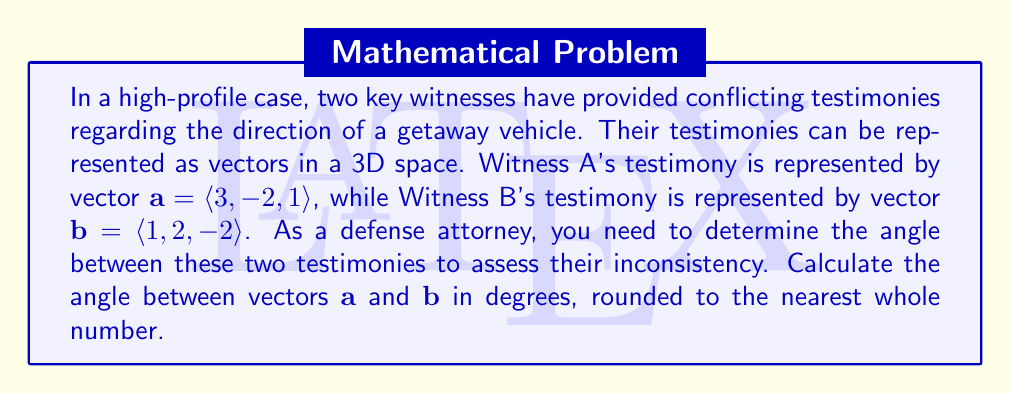Provide a solution to this math problem. To find the angle between two vectors, we can use the dot product formula:

$$\cos \theta = \frac{\mathbf{a} \cdot \mathbf{b}}{|\mathbf{a}||\mathbf{b}|}$$

Where $\theta$ is the angle between the vectors, $\mathbf{a} \cdot \mathbf{b}$ is the dot product, and $|\mathbf{a}|$ and $|\mathbf{b}|$ are the magnitudes of the vectors.

Step 1: Calculate the dot product $\mathbf{a} \cdot \mathbf{b}$
$$\mathbf{a} \cdot \mathbf{b} = (3)(1) + (-2)(2) + (1)(-2) = 3 - 4 - 2 = -3$$

Step 2: Calculate the magnitudes of the vectors
$$|\mathbf{a}| = \sqrt{3^2 + (-2)^2 + 1^2} = \sqrt{9 + 4 + 1} = \sqrt{14}$$
$$|\mathbf{b}| = \sqrt{1^2 + 2^2 + (-2)^2} = \sqrt{1 + 4 + 4} = 3$$

Step 3: Substitute into the dot product formula
$$\cos \theta = \frac{-3}{\sqrt{14} \cdot 3}$$

Step 4: Solve for $\theta$ using the inverse cosine function
$$\theta = \arccos\left(\frac{-3}{\sqrt{14} \cdot 3}\right)$$

Step 5: Convert to degrees and round to the nearest whole number
$$\theta \approx 106.60^\circ \approx 107^\circ$$
Answer: 107° 